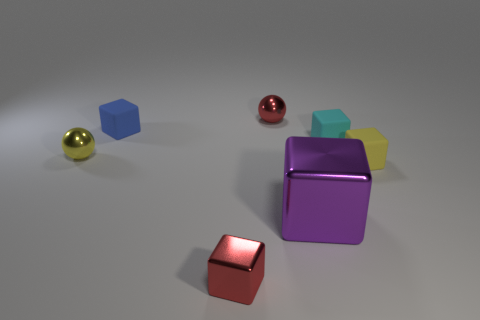Subtract 2 blocks. How many blocks are left? 3 Subtract all cyan blocks. How many blocks are left? 4 Subtract all yellow blocks. How many blocks are left? 4 Subtract all gray blocks. Subtract all gray cylinders. How many blocks are left? 5 Add 1 cyan objects. How many objects exist? 8 Subtract all cubes. How many objects are left? 2 Subtract 0 red cylinders. How many objects are left? 7 Subtract all large red metal spheres. Subtract all small yellow things. How many objects are left? 5 Add 2 things. How many things are left? 9 Add 4 tiny red balls. How many tiny red balls exist? 5 